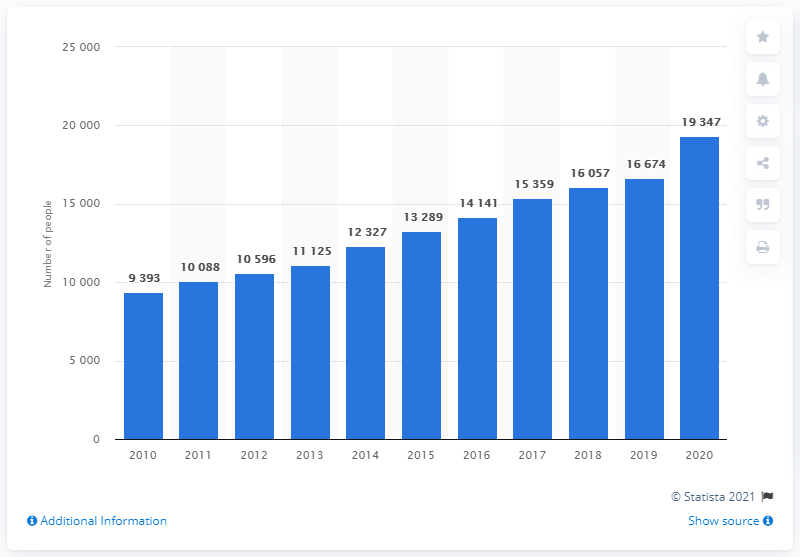Mention a couple of crucial points in this snapshot. In 2020, there were 19,347 Muslims of Finnish nationality. 